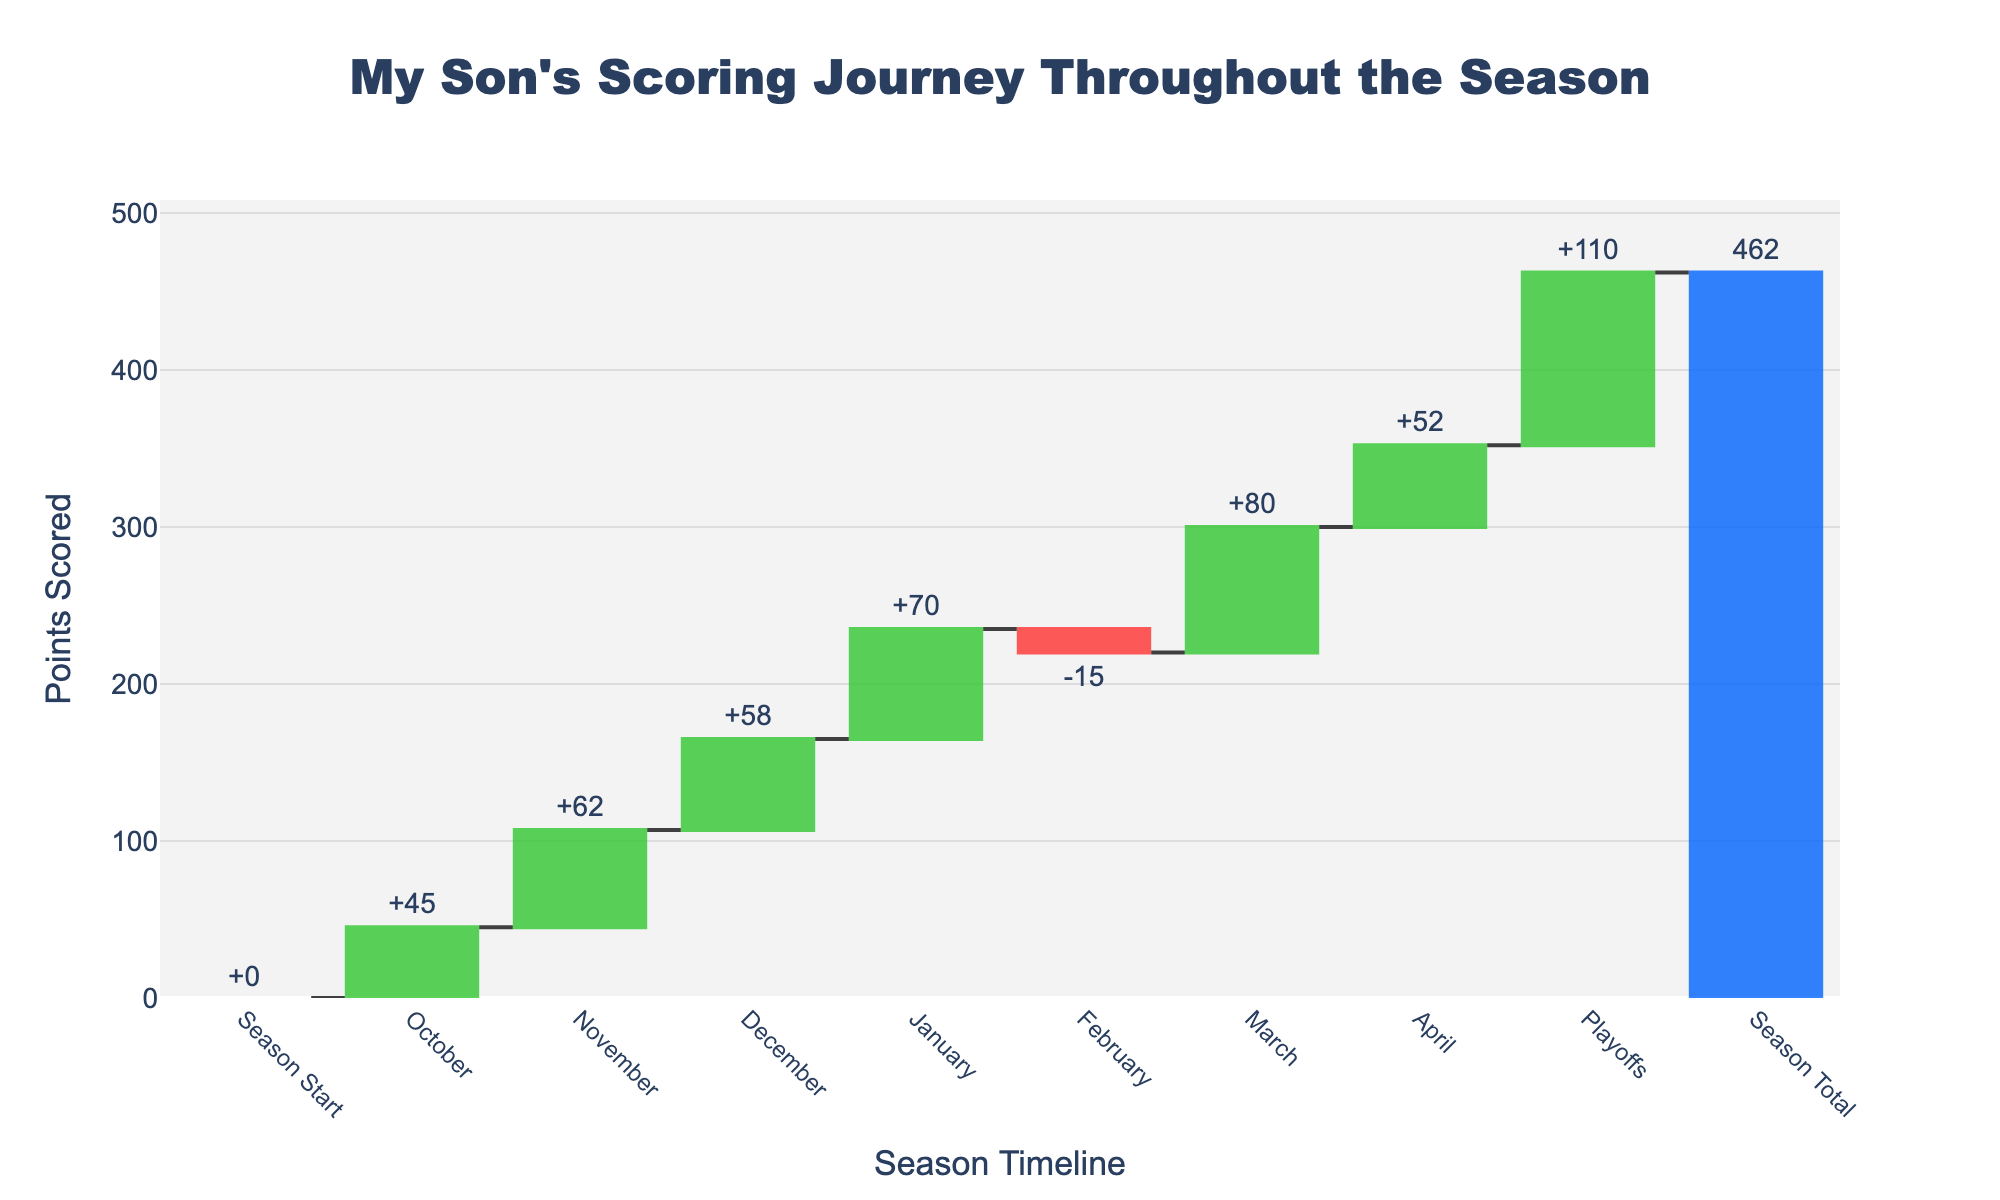What's the title of the figure? The title is displayed at the top of the chart and often summarizes the overall topic or main message of the figure. From the data and code provided, the title of the chart is given.
Answer: My Son's Scoring Journey Throughout the Season What's the value change in January? The figure shows each month's point contribution. Look at the January label to find the change.
Answer: +70 Which month has a negative value, and what is the value? Scan through the data labels on the x-axis for a negative value; it is February with a value of -15.
Answer: February, -15 What is the total score at the end of the season? The total score is presented under the 'Season Total' category, which sums up all the values.
Answer: 462 What month had the highest increase in points? Compare the monthly increases; March has the highest positive value of +80.
Answer: March How does the scoring in the playoffs compare to April? Compare the playoffs value with April's; Playoffs had +110 while April had +52.
Answer: Playoffs had higher scoring What's the difference in scoring between November and December? Find the values for November and December, then subtract November from December: +62 - +58.
Answer: 4 How many months show an increase in scoring? Count the months with positive values from October to April; October, November, December, January, March, and April.
Answer: 6 If you sum the scores from January and February, what do you get? January is +70 and February is -15; adding these together gives +70 - 15.
Answer: 55 What are the colors representing increasing, decreasing, and total values? From the code, increasing values are green, decreasing values are red, and the total value is blue.
Answer: Green, Red, Blue 